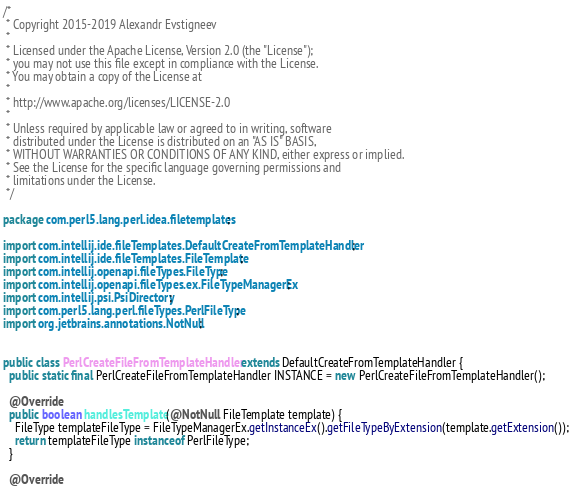Convert code to text. <code><loc_0><loc_0><loc_500><loc_500><_Java_>/*
 * Copyright 2015-2019 Alexandr Evstigneev
 *
 * Licensed under the Apache License, Version 2.0 (the "License");
 * you may not use this file except in compliance with the License.
 * You may obtain a copy of the License at
 *
 * http://www.apache.org/licenses/LICENSE-2.0
 *
 * Unless required by applicable law or agreed to in writing, software
 * distributed under the License is distributed on an "AS IS" BASIS,
 * WITHOUT WARRANTIES OR CONDITIONS OF ANY KIND, either express or implied.
 * See the License for the specific language governing permissions and
 * limitations under the License.
 */

package com.perl5.lang.perl.idea.filetemplates;

import com.intellij.ide.fileTemplates.DefaultCreateFromTemplateHandler;
import com.intellij.ide.fileTemplates.FileTemplate;
import com.intellij.openapi.fileTypes.FileType;
import com.intellij.openapi.fileTypes.ex.FileTypeManagerEx;
import com.intellij.psi.PsiDirectory;
import com.perl5.lang.perl.fileTypes.PerlFileType;
import org.jetbrains.annotations.NotNull;


public class PerlCreateFileFromTemplateHandler extends DefaultCreateFromTemplateHandler {
  public static final PerlCreateFileFromTemplateHandler INSTANCE = new PerlCreateFileFromTemplateHandler();

  @Override
  public boolean handlesTemplate(@NotNull FileTemplate template) {
    FileType templateFileType = FileTypeManagerEx.getInstanceEx().getFileTypeByExtension(template.getExtension());
    return templateFileType instanceof PerlFileType;
  }

  @Override</code> 